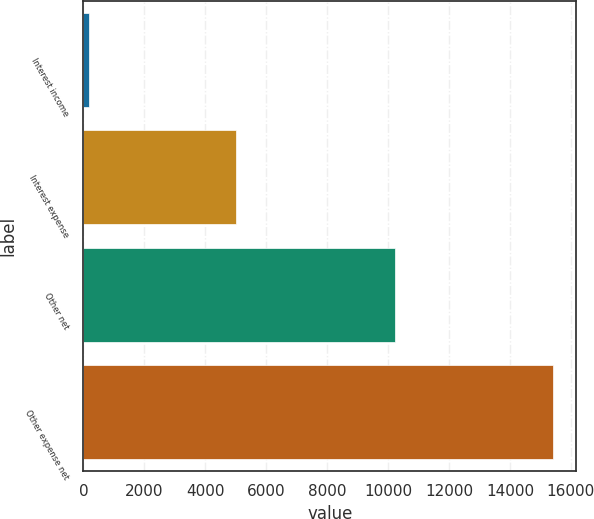Convert chart. <chart><loc_0><loc_0><loc_500><loc_500><bar_chart><fcel>Interest income<fcel>Interest expense<fcel>Other net<fcel>Other expense net<nl><fcel>176<fcel>4998<fcel>10233<fcel>15407<nl></chart> 